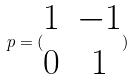<formula> <loc_0><loc_0><loc_500><loc_500>p = ( \begin{matrix} 1 & - 1 \\ 0 & 1 \end{matrix} )</formula> 